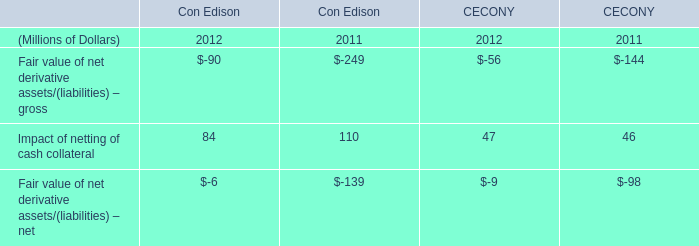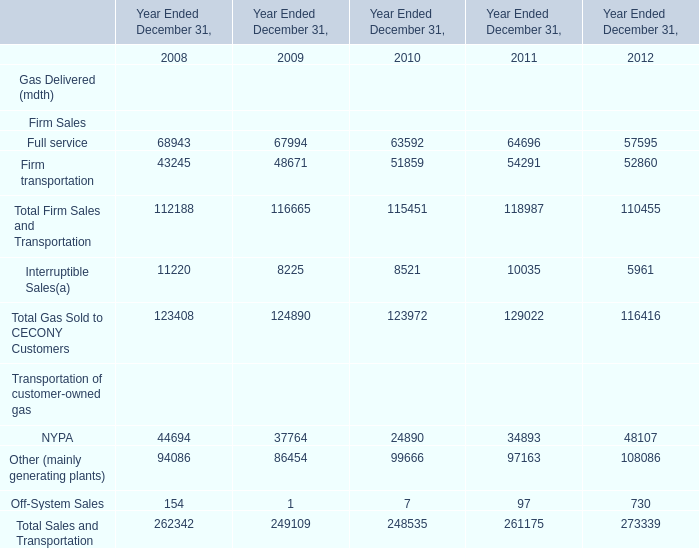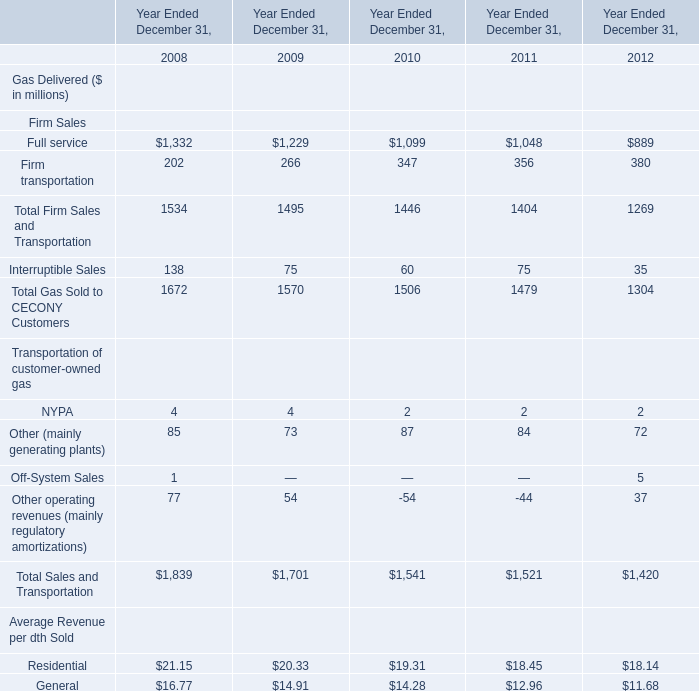What's the average of Full service of Year Ended December 31, 2009, and Firm transportation of Year Ended December 31, 2009 ? 
Computations: ((1229.0 + 48671.0) / 2)
Answer: 24950.0. 